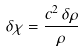Convert formula to latex. <formula><loc_0><loc_0><loc_500><loc_500>\delta \chi = \frac { c ^ { 2 } \, \delta \rho } { \rho }</formula> 